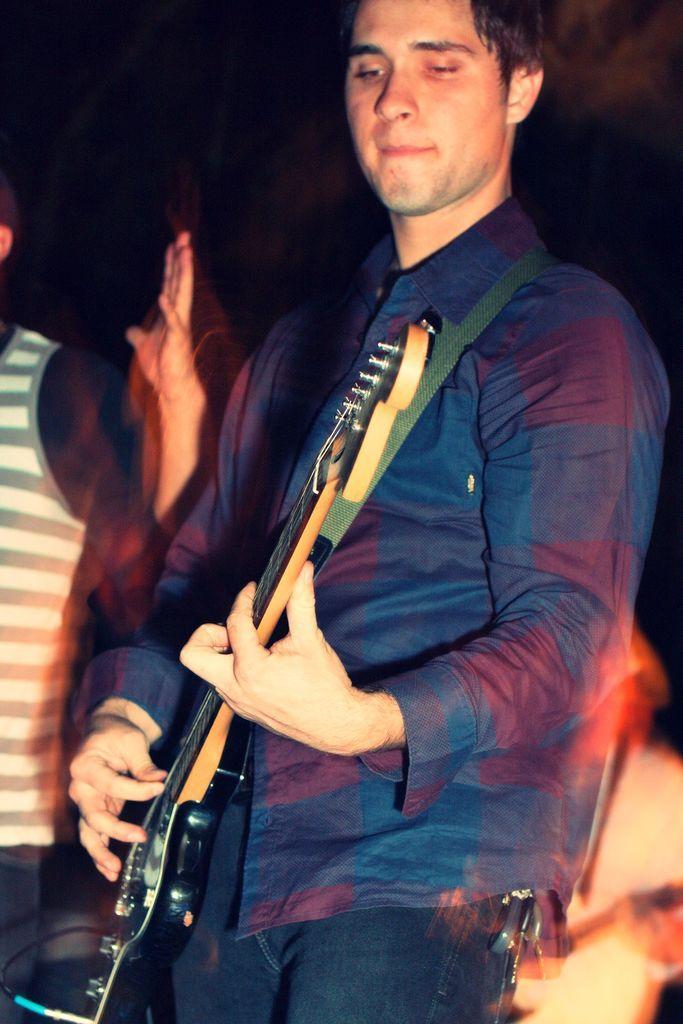In one or two sentences, can you explain what this image depicts? In this image we have a man standing and playing a guitar and at the back ground we have another person standing. 